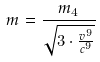Convert formula to latex. <formula><loc_0><loc_0><loc_500><loc_500>m = \frac { m _ { 4 } } { \sqrt { 3 \cdot \frac { v ^ { 9 } } { c ^ { 9 } } } }</formula> 